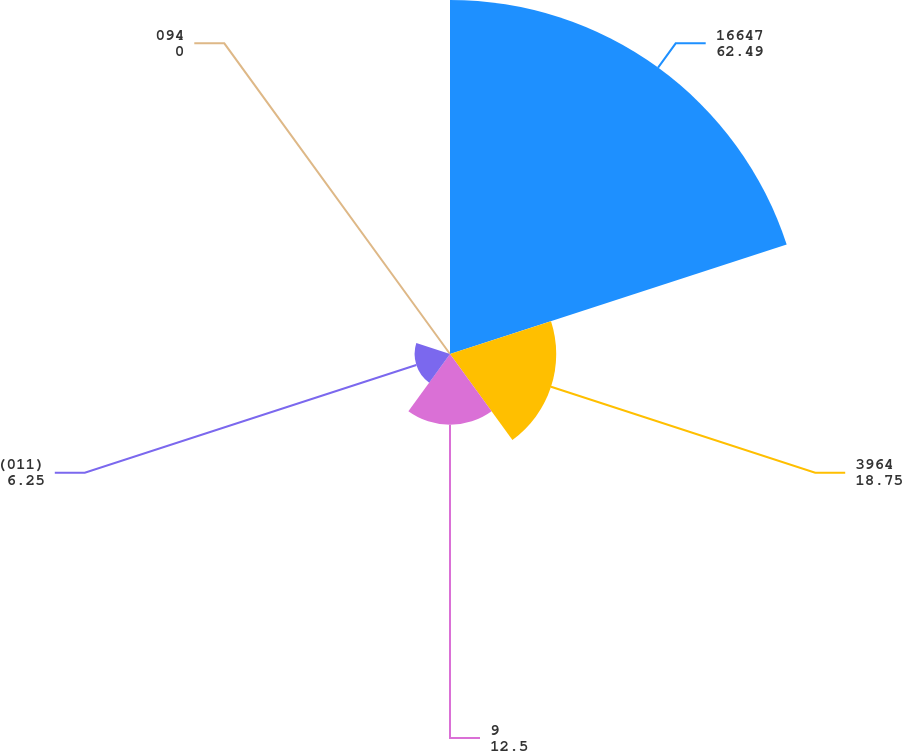Convert chart. <chart><loc_0><loc_0><loc_500><loc_500><pie_chart><fcel>16647<fcel>3964<fcel>9<fcel>(011)<fcel>094<nl><fcel>62.49%<fcel>18.75%<fcel>12.5%<fcel>6.25%<fcel>0.0%<nl></chart> 